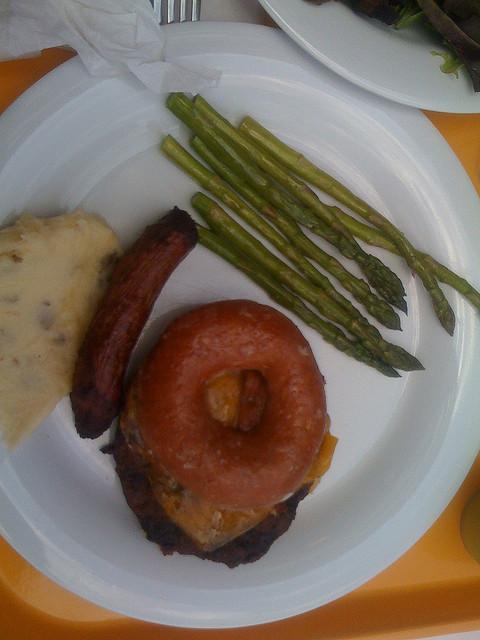Does any food man an X?
Concise answer only. No. What is the green vegetable?
Keep it brief. Asparagus. What color is the plate?
Keep it brief. White. What vegetable is that?
Be succinct. Asparagus. Is it true that large amounts of sugar will slow the body down?
Write a very short answer. Yes. What is green in this picture?
Give a very brief answer. Asparagus. Does this look like tasty gingerbread?
Answer briefly. No. 